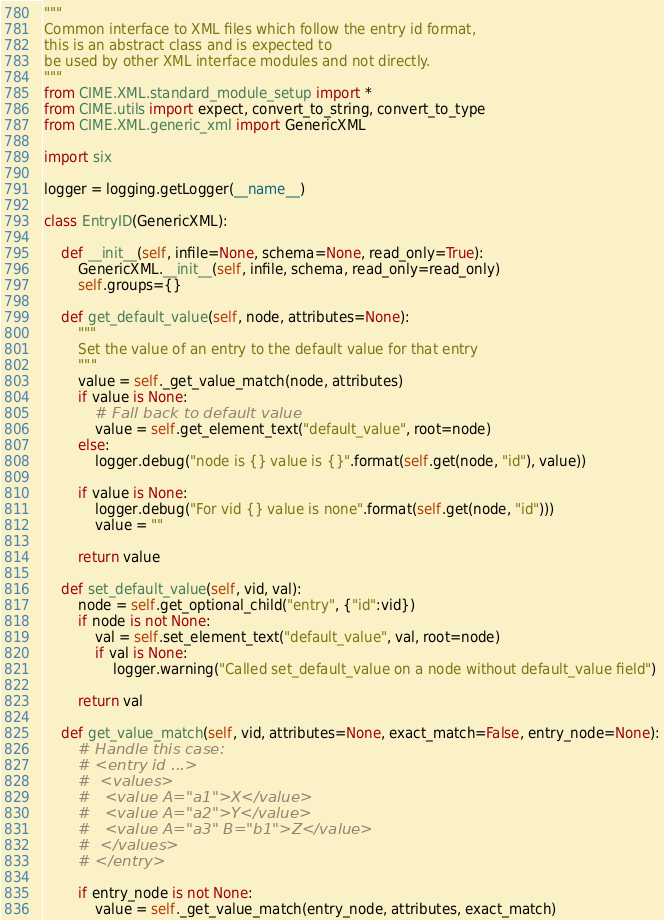<code> <loc_0><loc_0><loc_500><loc_500><_Python_>"""
Common interface to XML files which follow the entry id format,
this is an abstract class and is expected to
be used by other XML interface modules and not directly.
"""
from CIME.XML.standard_module_setup import *
from CIME.utils import expect, convert_to_string, convert_to_type
from CIME.XML.generic_xml import GenericXML

import six

logger = logging.getLogger(__name__)

class EntryID(GenericXML):

    def __init__(self, infile=None, schema=None, read_only=True):
        GenericXML.__init__(self, infile, schema, read_only=read_only)
        self.groups={}

    def get_default_value(self, node, attributes=None):
        """
        Set the value of an entry to the default value for that entry
        """
        value = self._get_value_match(node, attributes)
        if value is None:
            # Fall back to default value
            value = self.get_element_text("default_value", root=node)
        else:
            logger.debug("node is {} value is {}".format(self.get(node, "id"), value))

        if value is None:
            logger.debug("For vid {} value is none".format(self.get(node, "id")))
            value = ""

        return value

    def set_default_value(self, vid, val):
        node = self.get_optional_child("entry", {"id":vid})
        if node is not None:
            val = self.set_element_text("default_value", val, root=node)
            if val is None:
                logger.warning("Called set_default_value on a node without default_value field")

        return val

    def get_value_match(self, vid, attributes=None, exact_match=False, entry_node=None):
        # Handle this case:
        # <entry id ...>
        #  <values>
        #   <value A="a1">X</value>
        #   <value A="a2">Y</value>
        #   <value A="a3" B="b1">Z</value>
        #  </values>
        # </entry>

        if entry_node is not None:
            value = self._get_value_match(entry_node, attributes, exact_match)</code> 